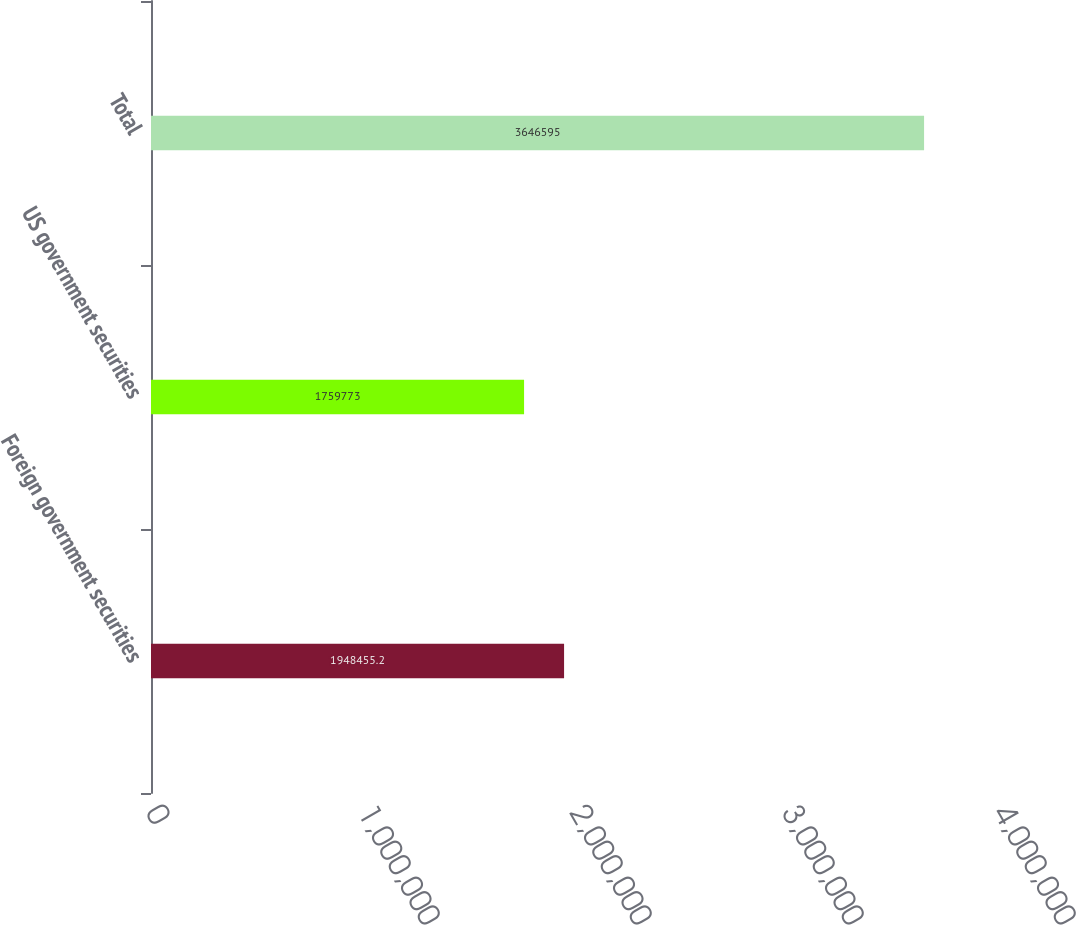<chart> <loc_0><loc_0><loc_500><loc_500><bar_chart><fcel>Foreign government securities<fcel>US government securities<fcel>Total<nl><fcel>1.94846e+06<fcel>1.75977e+06<fcel>3.6466e+06<nl></chart> 